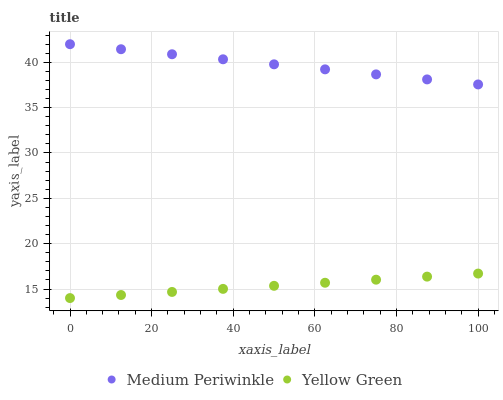Does Yellow Green have the minimum area under the curve?
Answer yes or no. Yes. Does Medium Periwinkle have the maximum area under the curve?
Answer yes or no. Yes. Does Yellow Green have the maximum area under the curve?
Answer yes or no. No. Is Yellow Green the smoothest?
Answer yes or no. Yes. Is Medium Periwinkle the roughest?
Answer yes or no. Yes. Is Yellow Green the roughest?
Answer yes or no. No. Does Yellow Green have the lowest value?
Answer yes or no. Yes. Does Medium Periwinkle have the highest value?
Answer yes or no. Yes. Does Yellow Green have the highest value?
Answer yes or no. No. Is Yellow Green less than Medium Periwinkle?
Answer yes or no. Yes. Is Medium Periwinkle greater than Yellow Green?
Answer yes or no. Yes. Does Yellow Green intersect Medium Periwinkle?
Answer yes or no. No. 